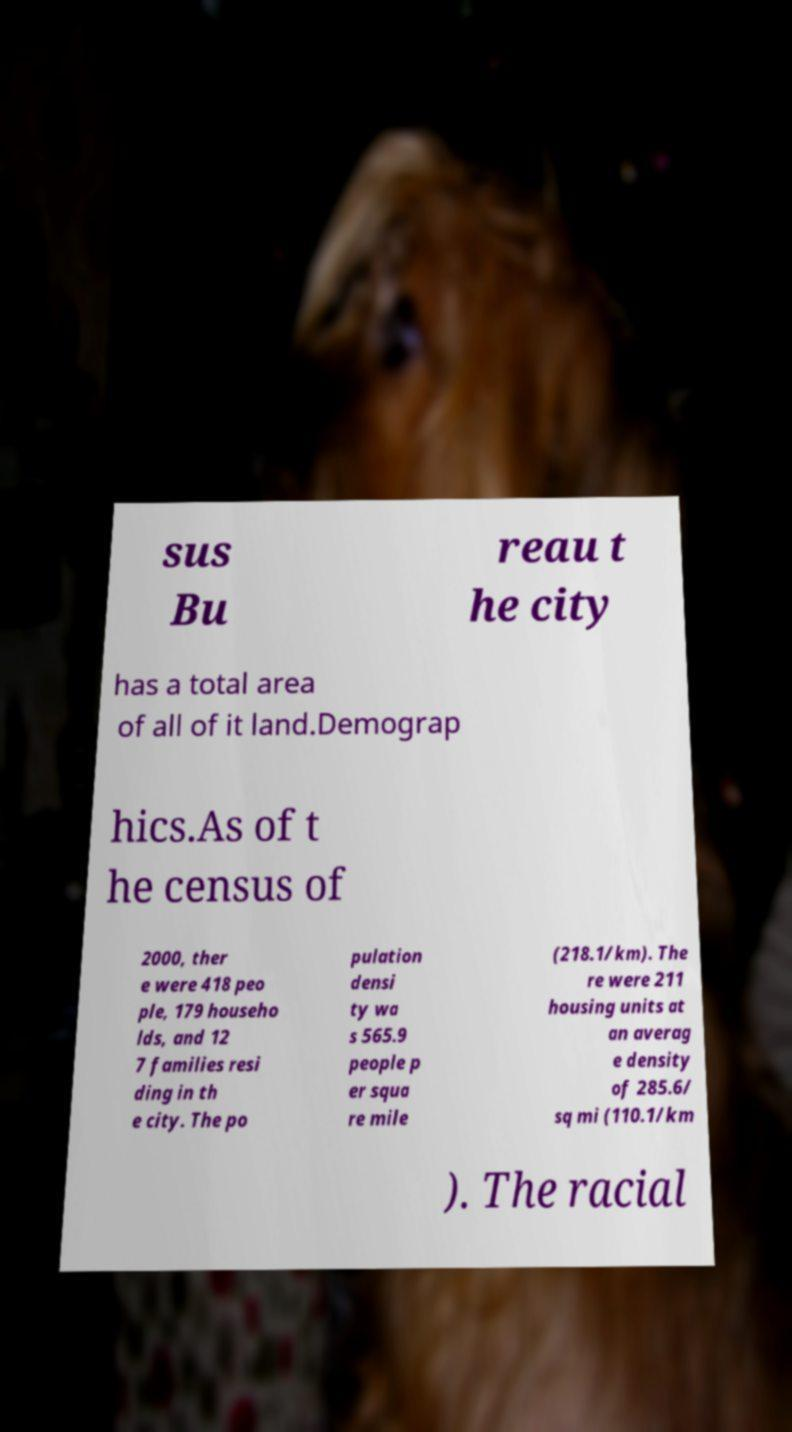Can you accurately transcribe the text from the provided image for me? sus Bu reau t he city has a total area of all of it land.Demograp hics.As of t he census of 2000, ther e were 418 peo ple, 179 househo lds, and 12 7 families resi ding in th e city. The po pulation densi ty wa s 565.9 people p er squa re mile (218.1/km). The re were 211 housing units at an averag e density of 285.6/ sq mi (110.1/km ). The racial 